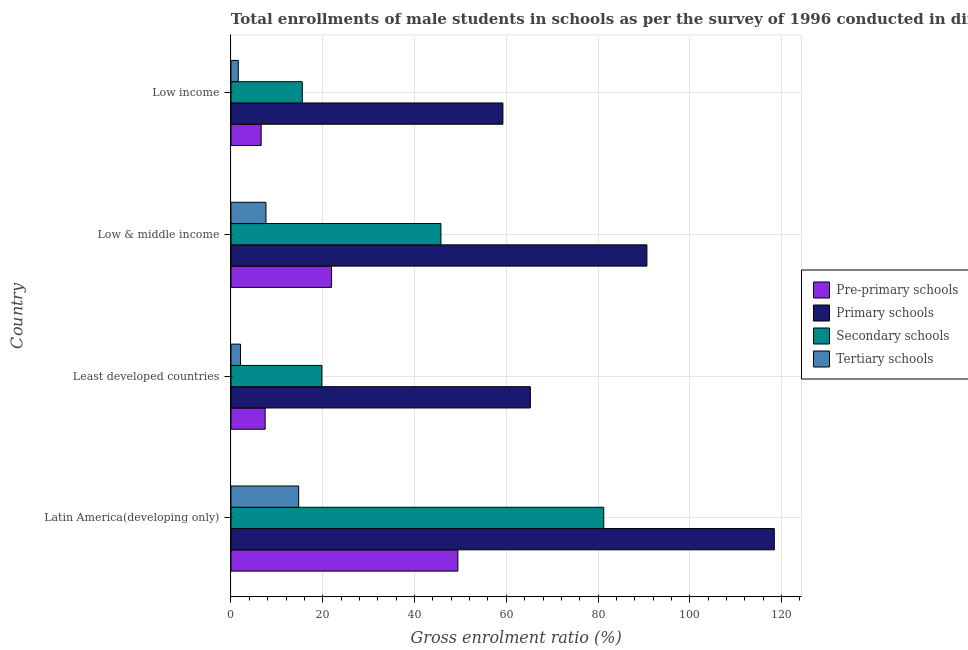Are the number of bars on each tick of the Y-axis equal?
Ensure brevity in your answer.  Yes. How many bars are there on the 1st tick from the bottom?
Offer a very short reply. 4. What is the gross enrolment ratio(male) in tertiary schools in Latin America(developing only)?
Offer a very short reply. 14.75. Across all countries, what is the maximum gross enrolment ratio(male) in secondary schools?
Your response must be concise. 81.24. Across all countries, what is the minimum gross enrolment ratio(male) in pre-primary schools?
Give a very brief answer. 6.58. In which country was the gross enrolment ratio(male) in pre-primary schools maximum?
Provide a short and direct response. Latin America(developing only). What is the total gross enrolment ratio(male) in pre-primary schools in the graph?
Your response must be concise. 85.38. What is the difference between the gross enrolment ratio(male) in tertiary schools in Least developed countries and that in Low & middle income?
Ensure brevity in your answer.  -5.54. What is the difference between the gross enrolment ratio(male) in primary schools in Least developed countries and the gross enrolment ratio(male) in tertiary schools in Low income?
Offer a very short reply. 63.65. What is the average gross enrolment ratio(male) in tertiary schools per country?
Offer a very short reply. 6.51. What is the difference between the gross enrolment ratio(male) in tertiary schools and gross enrolment ratio(male) in secondary schools in Least developed countries?
Your answer should be compact. -17.74. In how many countries, is the gross enrolment ratio(male) in primary schools greater than 4 %?
Offer a very short reply. 4. What is the ratio of the gross enrolment ratio(male) in tertiary schools in Least developed countries to that in Low & middle income?
Offer a very short reply. 0.27. What is the difference between the highest and the second highest gross enrolment ratio(male) in tertiary schools?
Provide a succinct answer. 7.13. What is the difference between the highest and the lowest gross enrolment ratio(male) in primary schools?
Offer a very short reply. 59.15. In how many countries, is the gross enrolment ratio(male) in pre-primary schools greater than the average gross enrolment ratio(male) in pre-primary schools taken over all countries?
Offer a terse response. 2. Is it the case that in every country, the sum of the gross enrolment ratio(male) in primary schools and gross enrolment ratio(male) in pre-primary schools is greater than the sum of gross enrolment ratio(male) in secondary schools and gross enrolment ratio(male) in tertiary schools?
Give a very brief answer. No. What does the 1st bar from the top in Low & middle income represents?
Your answer should be compact. Tertiary schools. What does the 1st bar from the bottom in Low income represents?
Offer a very short reply. Pre-primary schools. Is it the case that in every country, the sum of the gross enrolment ratio(male) in pre-primary schools and gross enrolment ratio(male) in primary schools is greater than the gross enrolment ratio(male) in secondary schools?
Offer a very short reply. Yes. Does the graph contain any zero values?
Keep it short and to the point. No. How many legend labels are there?
Your answer should be very brief. 4. What is the title of the graph?
Give a very brief answer. Total enrollments of male students in schools as per the survey of 1996 conducted in different countries. What is the label or title of the X-axis?
Offer a very short reply. Gross enrolment ratio (%). What is the Gross enrolment ratio (%) in Pre-primary schools in Latin America(developing only)?
Provide a short and direct response. 49.44. What is the Gross enrolment ratio (%) in Primary schools in Latin America(developing only)?
Provide a short and direct response. 118.41. What is the Gross enrolment ratio (%) in Secondary schools in Latin America(developing only)?
Make the answer very short. 81.24. What is the Gross enrolment ratio (%) of Tertiary schools in Latin America(developing only)?
Make the answer very short. 14.75. What is the Gross enrolment ratio (%) of Pre-primary schools in Least developed countries?
Make the answer very short. 7.44. What is the Gross enrolment ratio (%) in Primary schools in Least developed countries?
Provide a succinct answer. 65.25. What is the Gross enrolment ratio (%) in Secondary schools in Least developed countries?
Your answer should be compact. 19.82. What is the Gross enrolment ratio (%) of Tertiary schools in Least developed countries?
Your response must be concise. 2.08. What is the Gross enrolment ratio (%) of Pre-primary schools in Low & middle income?
Ensure brevity in your answer.  21.92. What is the Gross enrolment ratio (%) of Primary schools in Low & middle income?
Keep it short and to the point. 90.65. What is the Gross enrolment ratio (%) of Secondary schools in Low & middle income?
Offer a very short reply. 45.75. What is the Gross enrolment ratio (%) in Tertiary schools in Low & middle income?
Your answer should be compact. 7.63. What is the Gross enrolment ratio (%) of Pre-primary schools in Low income?
Keep it short and to the point. 6.58. What is the Gross enrolment ratio (%) in Primary schools in Low income?
Your answer should be compact. 59.26. What is the Gross enrolment ratio (%) of Secondary schools in Low income?
Your answer should be compact. 15.54. What is the Gross enrolment ratio (%) in Tertiary schools in Low income?
Your answer should be compact. 1.6. Across all countries, what is the maximum Gross enrolment ratio (%) in Pre-primary schools?
Your response must be concise. 49.44. Across all countries, what is the maximum Gross enrolment ratio (%) in Primary schools?
Your answer should be compact. 118.41. Across all countries, what is the maximum Gross enrolment ratio (%) of Secondary schools?
Your response must be concise. 81.24. Across all countries, what is the maximum Gross enrolment ratio (%) of Tertiary schools?
Your answer should be compact. 14.75. Across all countries, what is the minimum Gross enrolment ratio (%) of Pre-primary schools?
Provide a succinct answer. 6.58. Across all countries, what is the minimum Gross enrolment ratio (%) of Primary schools?
Keep it short and to the point. 59.26. Across all countries, what is the minimum Gross enrolment ratio (%) in Secondary schools?
Keep it short and to the point. 15.54. Across all countries, what is the minimum Gross enrolment ratio (%) in Tertiary schools?
Your response must be concise. 1.6. What is the total Gross enrolment ratio (%) of Pre-primary schools in the graph?
Ensure brevity in your answer.  85.38. What is the total Gross enrolment ratio (%) of Primary schools in the graph?
Give a very brief answer. 333.56. What is the total Gross enrolment ratio (%) in Secondary schools in the graph?
Provide a short and direct response. 162.34. What is the total Gross enrolment ratio (%) in Tertiary schools in the graph?
Ensure brevity in your answer.  26.05. What is the difference between the Gross enrolment ratio (%) of Pre-primary schools in Latin America(developing only) and that in Least developed countries?
Make the answer very short. 42. What is the difference between the Gross enrolment ratio (%) in Primary schools in Latin America(developing only) and that in Least developed countries?
Your answer should be very brief. 53.16. What is the difference between the Gross enrolment ratio (%) in Secondary schools in Latin America(developing only) and that in Least developed countries?
Provide a succinct answer. 61.42. What is the difference between the Gross enrolment ratio (%) of Tertiary schools in Latin America(developing only) and that in Least developed countries?
Ensure brevity in your answer.  12.67. What is the difference between the Gross enrolment ratio (%) of Pre-primary schools in Latin America(developing only) and that in Low & middle income?
Make the answer very short. 27.53. What is the difference between the Gross enrolment ratio (%) of Primary schools in Latin America(developing only) and that in Low & middle income?
Ensure brevity in your answer.  27.76. What is the difference between the Gross enrolment ratio (%) in Secondary schools in Latin America(developing only) and that in Low & middle income?
Offer a terse response. 35.49. What is the difference between the Gross enrolment ratio (%) in Tertiary schools in Latin America(developing only) and that in Low & middle income?
Your answer should be very brief. 7.13. What is the difference between the Gross enrolment ratio (%) of Pre-primary schools in Latin America(developing only) and that in Low income?
Ensure brevity in your answer.  42.87. What is the difference between the Gross enrolment ratio (%) of Primary schools in Latin America(developing only) and that in Low income?
Ensure brevity in your answer.  59.15. What is the difference between the Gross enrolment ratio (%) of Secondary schools in Latin America(developing only) and that in Low income?
Provide a short and direct response. 65.7. What is the difference between the Gross enrolment ratio (%) in Tertiary schools in Latin America(developing only) and that in Low income?
Provide a short and direct response. 13.16. What is the difference between the Gross enrolment ratio (%) in Pre-primary schools in Least developed countries and that in Low & middle income?
Provide a succinct answer. -14.47. What is the difference between the Gross enrolment ratio (%) in Primary schools in Least developed countries and that in Low & middle income?
Ensure brevity in your answer.  -25.4. What is the difference between the Gross enrolment ratio (%) in Secondary schools in Least developed countries and that in Low & middle income?
Ensure brevity in your answer.  -25.93. What is the difference between the Gross enrolment ratio (%) of Tertiary schools in Least developed countries and that in Low & middle income?
Your answer should be very brief. -5.54. What is the difference between the Gross enrolment ratio (%) in Pre-primary schools in Least developed countries and that in Low income?
Your answer should be compact. 0.87. What is the difference between the Gross enrolment ratio (%) in Primary schools in Least developed countries and that in Low income?
Your answer should be compact. 5.99. What is the difference between the Gross enrolment ratio (%) of Secondary schools in Least developed countries and that in Low income?
Offer a very short reply. 4.28. What is the difference between the Gross enrolment ratio (%) in Tertiary schools in Least developed countries and that in Low income?
Keep it short and to the point. 0.48. What is the difference between the Gross enrolment ratio (%) of Pre-primary schools in Low & middle income and that in Low income?
Give a very brief answer. 15.34. What is the difference between the Gross enrolment ratio (%) of Primary schools in Low & middle income and that in Low income?
Ensure brevity in your answer.  31.39. What is the difference between the Gross enrolment ratio (%) of Secondary schools in Low & middle income and that in Low income?
Offer a terse response. 30.21. What is the difference between the Gross enrolment ratio (%) of Tertiary schools in Low & middle income and that in Low income?
Provide a short and direct response. 6.03. What is the difference between the Gross enrolment ratio (%) of Pre-primary schools in Latin America(developing only) and the Gross enrolment ratio (%) of Primary schools in Least developed countries?
Ensure brevity in your answer.  -15.8. What is the difference between the Gross enrolment ratio (%) of Pre-primary schools in Latin America(developing only) and the Gross enrolment ratio (%) of Secondary schools in Least developed countries?
Ensure brevity in your answer.  29.63. What is the difference between the Gross enrolment ratio (%) of Pre-primary schools in Latin America(developing only) and the Gross enrolment ratio (%) of Tertiary schools in Least developed countries?
Your answer should be very brief. 47.36. What is the difference between the Gross enrolment ratio (%) in Primary schools in Latin America(developing only) and the Gross enrolment ratio (%) in Secondary schools in Least developed countries?
Make the answer very short. 98.59. What is the difference between the Gross enrolment ratio (%) of Primary schools in Latin America(developing only) and the Gross enrolment ratio (%) of Tertiary schools in Least developed countries?
Give a very brief answer. 116.33. What is the difference between the Gross enrolment ratio (%) of Secondary schools in Latin America(developing only) and the Gross enrolment ratio (%) of Tertiary schools in Least developed countries?
Provide a short and direct response. 79.16. What is the difference between the Gross enrolment ratio (%) in Pre-primary schools in Latin America(developing only) and the Gross enrolment ratio (%) in Primary schools in Low & middle income?
Your answer should be compact. -41.2. What is the difference between the Gross enrolment ratio (%) in Pre-primary schools in Latin America(developing only) and the Gross enrolment ratio (%) in Secondary schools in Low & middle income?
Your answer should be compact. 3.69. What is the difference between the Gross enrolment ratio (%) of Pre-primary schools in Latin America(developing only) and the Gross enrolment ratio (%) of Tertiary schools in Low & middle income?
Your answer should be compact. 41.82. What is the difference between the Gross enrolment ratio (%) of Primary schools in Latin America(developing only) and the Gross enrolment ratio (%) of Secondary schools in Low & middle income?
Your answer should be compact. 72.66. What is the difference between the Gross enrolment ratio (%) of Primary schools in Latin America(developing only) and the Gross enrolment ratio (%) of Tertiary schools in Low & middle income?
Make the answer very short. 110.78. What is the difference between the Gross enrolment ratio (%) of Secondary schools in Latin America(developing only) and the Gross enrolment ratio (%) of Tertiary schools in Low & middle income?
Offer a very short reply. 73.61. What is the difference between the Gross enrolment ratio (%) of Pre-primary schools in Latin America(developing only) and the Gross enrolment ratio (%) of Primary schools in Low income?
Your response must be concise. -9.82. What is the difference between the Gross enrolment ratio (%) in Pre-primary schools in Latin America(developing only) and the Gross enrolment ratio (%) in Secondary schools in Low income?
Your answer should be very brief. 33.91. What is the difference between the Gross enrolment ratio (%) of Pre-primary schools in Latin America(developing only) and the Gross enrolment ratio (%) of Tertiary schools in Low income?
Provide a short and direct response. 47.85. What is the difference between the Gross enrolment ratio (%) of Primary schools in Latin America(developing only) and the Gross enrolment ratio (%) of Secondary schools in Low income?
Your answer should be compact. 102.87. What is the difference between the Gross enrolment ratio (%) in Primary schools in Latin America(developing only) and the Gross enrolment ratio (%) in Tertiary schools in Low income?
Ensure brevity in your answer.  116.81. What is the difference between the Gross enrolment ratio (%) in Secondary schools in Latin America(developing only) and the Gross enrolment ratio (%) in Tertiary schools in Low income?
Your answer should be compact. 79.64. What is the difference between the Gross enrolment ratio (%) in Pre-primary schools in Least developed countries and the Gross enrolment ratio (%) in Primary schools in Low & middle income?
Provide a short and direct response. -83.2. What is the difference between the Gross enrolment ratio (%) of Pre-primary schools in Least developed countries and the Gross enrolment ratio (%) of Secondary schools in Low & middle income?
Make the answer very short. -38.31. What is the difference between the Gross enrolment ratio (%) in Pre-primary schools in Least developed countries and the Gross enrolment ratio (%) in Tertiary schools in Low & middle income?
Give a very brief answer. -0.18. What is the difference between the Gross enrolment ratio (%) of Primary schools in Least developed countries and the Gross enrolment ratio (%) of Secondary schools in Low & middle income?
Keep it short and to the point. 19.5. What is the difference between the Gross enrolment ratio (%) in Primary schools in Least developed countries and the Gross enrolment ratio (%) in Tertiary schools in Low & middle income?
Provide a short and direct response. 57.62. What is the difference between the Gross enrolment ratio (%) of Secondary schools in Least developed countries and the Gross enrolment ratio (%) of Tertiary schools in Low & middle income?
Offer a very short reply. 12.19. What is the difference between the Gross enrolment ratio (%) of Pre-primary schools in Least developed countries and the Gross enrolment ratio (%) of Primary schools in Low income?
Provide a succinct answer. -51.82. What is the difference between the Gross enrolment ratio (%) in Pre-primary schools in Least developed countries and the Gross enrolment ratio (%) in Secondary schools in Low income?
Offer a very short reply. -8.09. What is the difference between the Gross enrolment ratio (%) in Pre-primary schools in Least developed countries and the Gross enrolment ratio (%) in Tertiary schools in Low income?
Your answer should be compact. 5.85. What is the difference between the Gross enrolment ratio (%) of Primary schools in Least developed countries and the Gross enrolment ratio (%) of Secondary schools in Low income?
Provide a succinct answer. 49.71. What is the difference between the Gross enrolment ratio (%) in Primary schools in Least developed countries and the Gross enrolment ratio (%) in Tertiary schools in Low income?
Provide a short and direct response. 63.65. What is the difference between the Gross enrolment ratio (%) in Secondary schools in Least developed countries and the Gross enrolment ratio (%) in Tertiary schools in Low income?
Give a very brief answer. 18.22. What is the difference between the Gross enrolment ratio (%) in Pre-primary schools in Low & middle income and the Gross enrolment ratio (%) in Primary schools in Low income?
Ensure brevity in your answer.  -37.34. What is the difference between the Gross enrolment ratio (%) of Pre-primary schools in Low & middle income and the Gross enrolment ratio (%) of Secondary schools in Low income?
Give a very brief answer. 6.38. What is the difference between the Gross enrolment ratio (%) of Pre-primary schools in Low & middle income and the Gross enrolment ratio (%) of Tertiary schools in Low income?
Offer a terse response. 20.32. What is the difference between the Gross enrolment ratio (%) of Primary schools in Low & middle income and the Gross enrolment ratio (%) of Secondary schools in Low income?
Keep it short and to the point. 75.11. What is the difference between the Gross enrolment ratio (%) of Primary schools in Low & middle income and the Gross enrolment ratio (%) of Tertiary schools in Low income?
Your answer should be compact. 89.05. What is the difference between the Gross enrolment ratio (%) of Secondary schools in Low & middle income and the Gross enrolment ratio (%) of Tertiary schools in Low income?
Your answer should be very brief. 44.16. What is the average Gross enrolment ratio (%) in Pre-primary schools per country?
Offer a terse response. 21.35. What is the average Gross enrolment ratio (%) in Primary schools per country?
Your answer should be compact. 83.39. What is the average Gross enrolment ratio (%) in Secondary schools per country?
Your answer should be compact. 40.59. What is the average Gross enrolment ratio (%) of Tertiary schools per country?
Your response must be concise. 6.51. What is the difference between the Gross enrolment ratio (%) of Pre-primary schools and Gross enrolment ratio (%) of Primary schools in Latin America(developing only)?
Offer a terse response. -68.96. What is the difference between the Gross enrolment ratio (%) in Pre-primary schools and Gross enrolment ratio (%) in Secondary schools in Latin America(developing only)?
Ensure brevity in your answer.  -31.8. What is the difference between the Gross enrolment ratio (%) in Pre-primary schools and Gross enrolment ratio (%) in Tertiary schools in Latin America(developing only)?
Your answer should be compact. 34.69. What is the difference between the Gross enrolment ratio (%) in Primary schools and Gross enrolment ratio (%) in Secondary schools in Latin America(developing only)?
Give a very brief answer. 37.17. What is the difference between the Gross enrolment ratio (%) in Primary schools and Gross enrolment ratio (%) in Tertiary schools in Latin America(developing only)?
Make the answer very short. 103.65. What is the difference between the Gross enrolment ratio (%) in Secondary schools and Gross enrolment ratio (%) in Tertiary schools in Latin America(developing only)?
Offer a terse response. 66.49. What is the difference between the Gross enrolment ratio (%) of Pre-primary schools and Gross enrolment ratio (%) of Primary schools in Least developed countries?
Your answer should be very brief. -57.8. What is the difference between the Gross enrolment ratio (%) in Pre-primary schools and Gross enrolment ratio (%) in Secondary schools in Least developed countries?
Give a very brief answer. -12.37. What is the difference between the Gross enrolment ratio (%) in Pre-primary schools and Gross enrolment ratio (%) in Tertiary schools in Least developed countries?
Provide a succinct answer. 5.36. What is the difference between the Gross enrolment ratio (%) of Primary schools and Gross enrolment ratio (%) of Secondary schools in Least developed countries?
Your response must be concise. 45.43. What is the difference between the Gross enrolment ratio (%) in Primary schools and Gross enrolment ratio (%) in Tertiary schools in Least developed countries?
Your answer should be compact. 63.17. What is the difference between the Gross enrolment ratio (%) in Secondary schools and Gross enrolment ratio (%) in Tertiary schools in Least developed countries?
Your answer should be very brief. 17.74. What is the difference between the Gross enrolment ratio (%) in Pre-primary schools and Gross enrolment ratio (%) in Primary schools in Low & middle income?
Give a very brief answer. -68.73. What is the difference between the Gross enrolment ratio (%) of Pre-primary schools and Gross enrolment ratio (%) of Secondary schools in Low & middle income?
Give a very brief answer. -23.83. What is the difference between the Gross enrolment ratio (%) in Pre-primary schools and Gross enrolment ratio (%) in Tertiary schools in Low & middle income?
Your answer should be compact. 14.29. What is the difference between the Gross enrolment ratio (%) in Primary schools and Gross enrolment ratio (%) in Secondary schools in Low & middle income?
Your answer should be compact. 44.9. What is the difference between the Gross enrolment ratio (%) of Primary schools and Gross enrolment ratio (%) of Tertiary schools in Low & middle income?
Give a very brief answer. 83.02. What is the difference between the Gross enrolment ratio (%) in Secondary schools and Gross enrolment ratio (%) in Tertiary schools in Low & middle income?
Provide a short and direct response. 38.13. What is the difference between the Gross enrolment ratio (%) of Pre-primary schools and Gross enrolment ratio (%) of Primary schools in Low income?
Your response must be concise. -52.68. What is the difference between the Gross enrolment ratio (%) in Pre-primary schools and Gross enrolment ratio (%) in Secondary schools in Low income?
Your answer should be compact. -8.96. What is the difference between the Gross enrolment ratio (%) of Pre-primary schools and Gross enrolment ratio (%) of Tertiary schools in Low income?
Ensure brevity in your answer.  4.98. What is the difference between the Gross enrolment ratio (%) of Primary schools and Gross enrolment ratio (%) of Secondary schools in Low income?
Offer a very short reply. 43.72. What is the difference between the Gross enrolment ratio (%) in Primary schools and Gross enrolment ratio (%) in Tertiary schools in Low income?
Provide a succinct answer. 57.66. What is the difference between the Gross enrolment ratio (%) of Secondary schools and Gross enrolment ratio (%) of Tertiary schools in Low income?
Keep it short and to the point. 13.94. What is the ratio of the Gross enrolment ratio (%) in Pre-primary schools in Latin America(developing only) to that in Least developed countries?
Your answer should be very brief. 6.64. What is the ratio of the Gross enrolment ratio (%) in Primary schools in Latin America(developing only) to that in Least developed countries?
Make the answer very short. 1.81. What is the ratio of the Gross enrolment ratio (%) in Secondary schools in Latin America(developing only) to that in Least developed countries?
Your response must be concise. 4.1. What is the ratio of the Gross enrolment ratio (%) in Tertiary schools in Latin America(developing only) to that in Least developed countries?
Give a very brief answer. 7.09. What is the ratio of the Gross enrolment ratio (%) in Pre-primary schools in Latin America(developing only) to that in Low & middle income?
Provide a short and direct response. 2.26. What is the ratio of the Gross enrolment ratio (%) in Primary schools in Latin America(developing only) to that in Low & middle income?
Your answer should be compact. 1.31. What is the ratio of the Gross enrolment ratio (%) in Secondary schools in Latin America(developing only) to that in Low & middle income?
Offer a terse response. 1.78. What is the ratio of the Gross enrolment ratio (%) in Tertiary schools in Latin America(developing only) to that in Low & middle income?
Your answer should be very brief. 1.93. What is the ratio of the Gross enrolment ratio (%) of Pre-primary schools in Latin America(developing only) to that in Low income?
Ensure brevity in your answer.  7.52. What is the ratio of the Gross enrolment ratio (%) of Primary schools in Latin America(developing only) to that in Low income?
Ensure brevity in your answer.  2. What is the ratio of the Gross enrolment ratio (%) of Secondary schools in Latin America(developing only) to that in Low income?
Provide a succinct answer. 5.23. What is the ratio of the Gross enrolment ratio (%) of Tertiary schools in Latin America(developing only) to that in Low income?
Offer a terse response. 9.25. What is the ratio of the Gross enrolment ratio (%) in Pre-primary schools in Least developed countries to that in Low & middle income?
Keep it short and to the point. 0.34. What is the ratio of the Gross enrolment ratio (%) in Primary schools in Least developed countries to that in Low & middle income?
Offer a terse response. 0.72. What is the ratio of the Gross enrolment ratio (%) of Secondary schools in Least developed countries to that in Low & middle income?
Keep it short and to the point. 0.43. What is the ratio of the Gross enrolment ratio (%) in Tertiary schools in Least developed countries to that in Low & middle income?
Provide a short and direct response. 0.27. What is the ratio of the Gross enrolment ratio (%) in Pre-primary schools in Least developed countries to that in Low income?
Ensure brevity in your answer.  1.13. What is the ratio of the Gross enrolment ratio (%) of Primary schools in Least developed countries to that in Low income?
Provide a succinct answer. 1.1. What is the ratio of the Gross enrolment ratio (%) of Secondary schools in Least developed countries to that in Low income?
Provide a short and direct response. 1.28. What is the ratio of the Gross enrolment ratio (%) of Tertiary schools in Least developed countries to that in Low income?
Your answer should be compact. 1.3. What is the ratio of the Gross enrolment ratio (%) of Pre-primary schools in Low & middle income to that in Low income?
Give a very brief answer. 3.33. What is the ratio of the Gross enrolment ratio (%) of Primary schools in Low & middle income to that in Low income?
Provide a succinct answer. 1.53. What is the ratio of the Gross enrolment ratio (%) of Secondary schools in Low & middle income to that in Low income?
Your answer should be very brief. 2.94. What is the ratio of the Gross enrolment ratio (%) in Tertiary schools in Low & middle income to that in Low income?
Offer a very short reply. 4.78. What is the difference between the highest and the second highest Gross enrolment ratio (%) of Pre-primary schools?
Keep it short and to the point. 27.53. What is the difference between the highest and the second highest Gross enrolment ratio (%) of Primary schools?
Provide a succinct answer. 27.76. What is the difference between the highest and the second highest Gross enrolment ratio (%) in Secondary schools?
Your answer should be compact. 35.49. What is the difference between the highest and the second highest Gross enrolment ratio (%) of Tertiary schools?
Your answer should be very brief. 7.13. What is the difference between the highest and the lowest Gross enrolment ratio (%) of Pre-primary schools?
Make the answer very short. 42.87. What is the difference between the highest and the lowest Gross enrolment ratio (%) of Primary schools?
Offer a terse response. 59.15. What is the difference between the highest and the lowest Gross enrolment ratio (%) in Secondary schools?
Your answer should be compact. 65.7. What is the difference between the highest and the lowest Gross enrolment ratio (%) in Tertiary schools?
Offer a terse response. 13.16. 